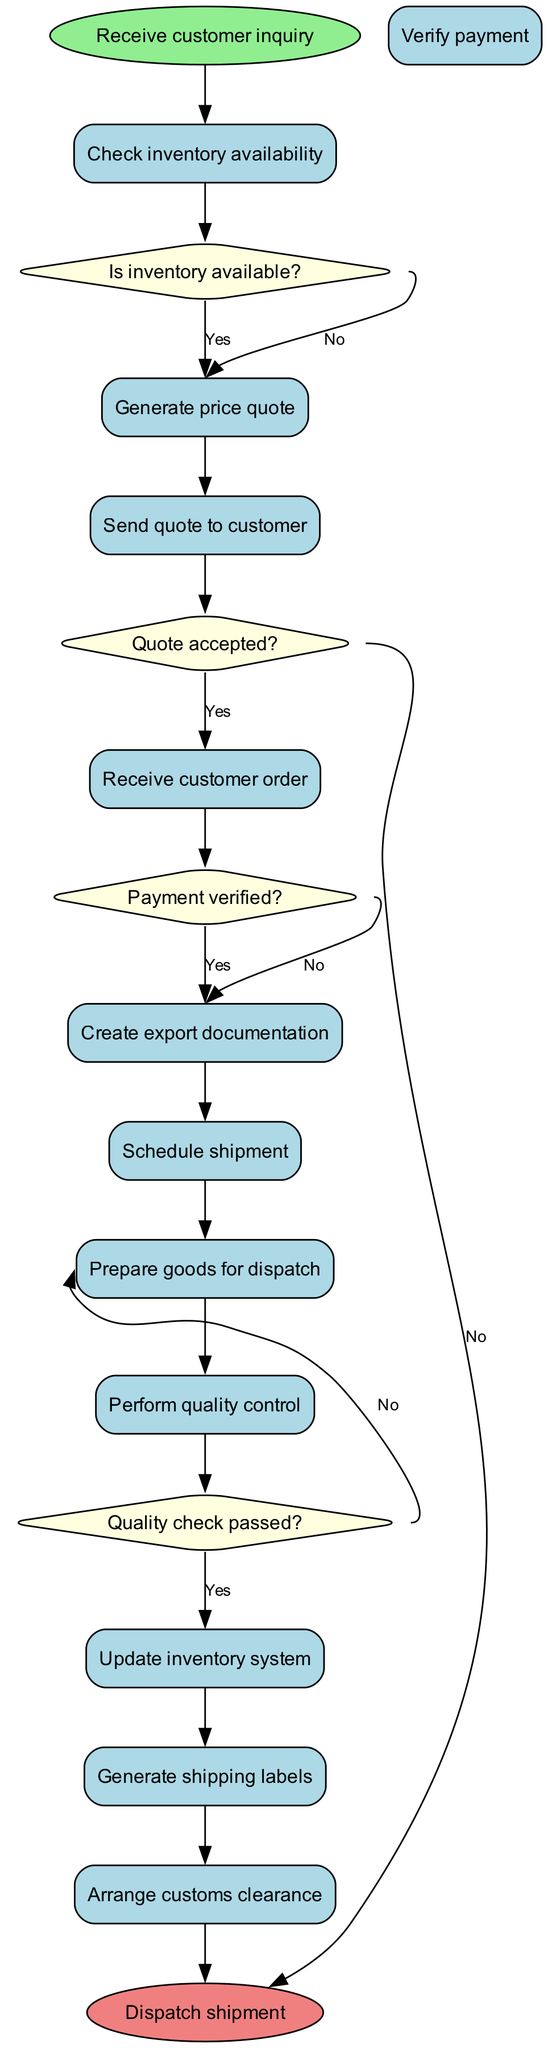What is the initial node in the diagram? The initial node in the diagram represents where the workflow starts. It is labeled as "Receive customer inquiry".
Answer: Receive customer inquiry How many activities are listed in the workflow? The workflow includes a list of activities involved in the order processing. There are a total of 12 activities listed, including preparation for dispatch.
Answer: 12 What decision follows the "Check inventory availability" activity? After the activity "Check inventory availability", the next decision is based on the condition "Is inventory available?". This decision determines the flow based on inventory status.
Answer: Is inventory available? What happens if the quote is not accepted? If the quote is not accepted, per the diagram, the workflow ends immediately without progressing to the next activities.
Answer: End process Which activity occurs after "Prepare goods for dispatch"? After "Prepare goods for dispatch", the next activity in the workflow is "Perform quality control", which is a crucial step to ensure the quality of goods before they are shipped.
Answer: Perform quality control If the quality check fails, what does the workflow dictate? If the quality check fails, the flow redirects to the "Address quality issues" activity, which indicates that action must be taken to resolve any quality concerns before proceeding.
Answer: Address quality issues What is the final node of the process? The final node signifies the endpoint of the order processing workflow, which in this case is when the shipment has been dispatched to the customer.
Answer: Dispatch shipment How many decision points are there in the diagram? The diagram shows a total of four decision points that guide the workflow based on specific conditions such as inventory availability and payment verification.
Answer: 4 What is the relationship between "Verify payment" and "Create export documentation"? The relationship between "Verify payment" and "Create export documentation" is dependent on the decision "Payment verified?". If the payment is verified, it leads directly to creating export documentation.
Answer: Payment verified? 